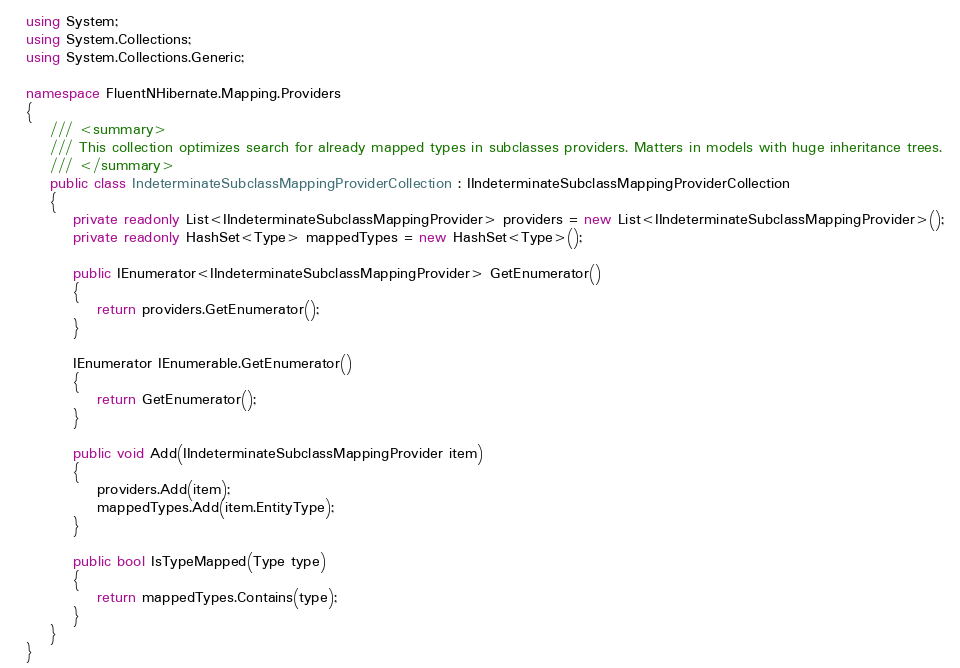Convert code to text. <code><loc_0><loc_0><loc_500><loc_500><_C#_>using System;
using System.Collections;
using System.Collections.Generic;

namespace FluentNHibernate.Mapping.Providers
{
    /// <summary>
    /// This collection optimizes search for already mapped types in subclasses providers. Matters in models with huge inheritance trees.
    /// </summary>
    public class IndeterminateSubclassMappingProviderCollection : IIndeterminateSubclassMappingProviderCollection
    {
        private readonly List<IIndeterminateSubclassMappingProvider> providers = new List<IIndeterminateSubclassMappingProvider>(); 
        private readonly HashSet<Type> mappedTypes = new HashSet<Type>(); 

        public IEnumerator<IIndeterminateSubclassMappingProvider> GetEnumerator()
        {
            return providers.GetEnumerator();
        }

        IEnumerator IEnumerable.GetEnumerator()
        {
            return GetEnumerator();
        }

        public void Add(IIndeterminateSubclassMappingProvider item)
        {
            providers.Add(item);
            mappedTypes.Add(item.EntityType);
        }

        public bool IsTypeMapped(Type type)
        {
            return mappedTypes.Contains(type);
        }
    }
}</code> 